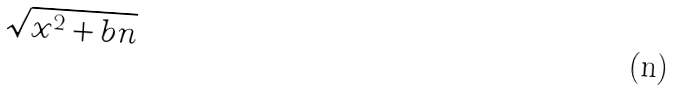<formula> <loc_0><loc_0><loc_500><loc_500>\sqrt { x ^ { 2 } + b n }</formula> 